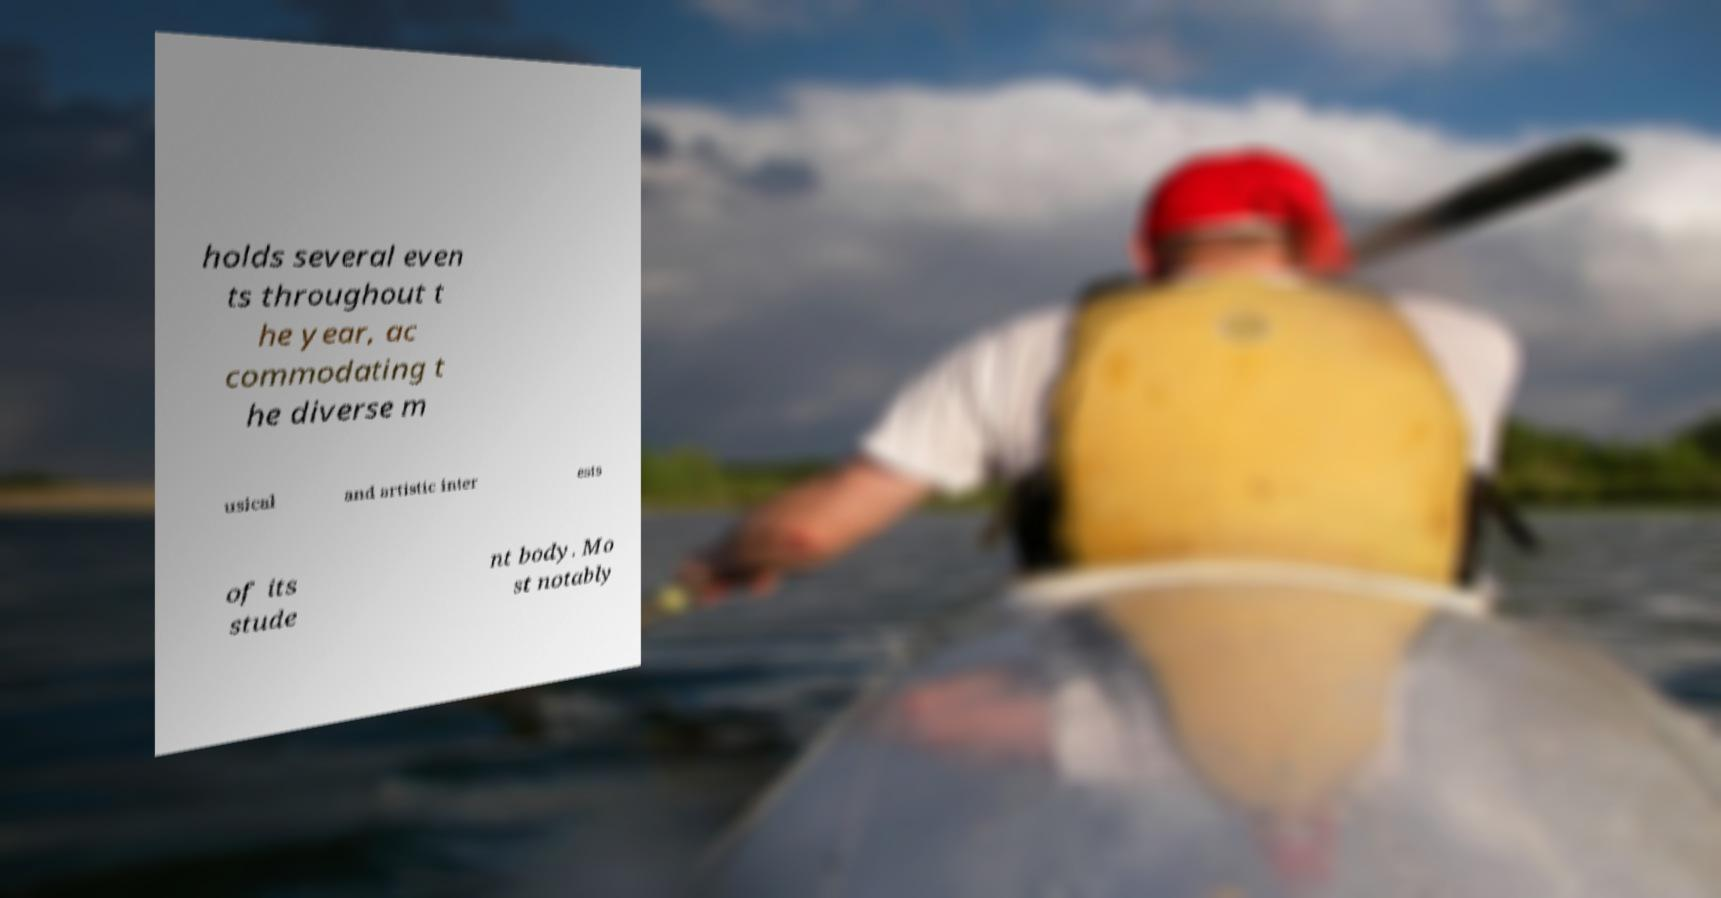What messages or text are displayed in this image? I need them in a readable, typed format. holds several even ts throughout t he year, ac commodating t he diverse m usical and artistic inter ests of its stude nt body. Mo st notably 